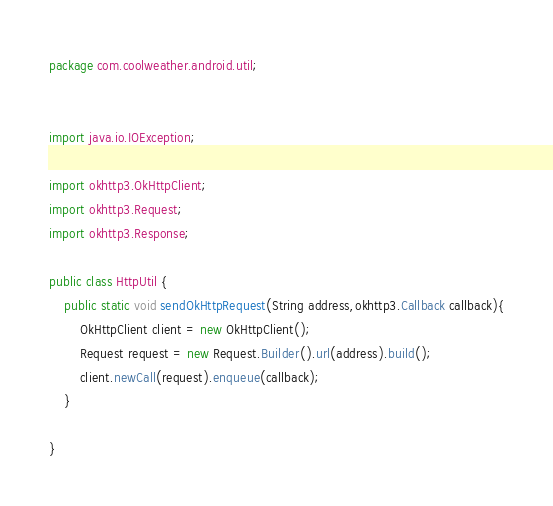Convert code to text. <code><loc_0><loc_0><loc_500><loc_500><_Java_>package com.coolweather.android.util;


import java.io.IOException;

import okhttp3.OkHttpClient;
import okhttp3.Request;
import okhttp3.Response;

public class HttpUtil {
    public static void sendOkHttpRequest(String address,okhttp3.Callback callback){
        OkHttpClient client = new OkHttpClient();
        Request request = new Request.Builder().url(address).build();
        client.newCall(request).enqueue(callback);
    }

}
</code> 